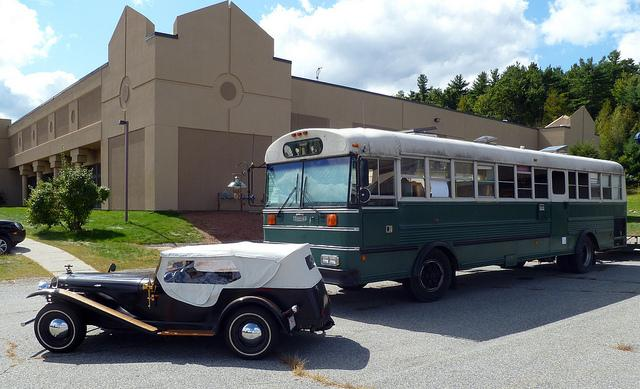Who is in danger of being struc?

Choices:
A) car
B) bus
C) building
D) parked car car 